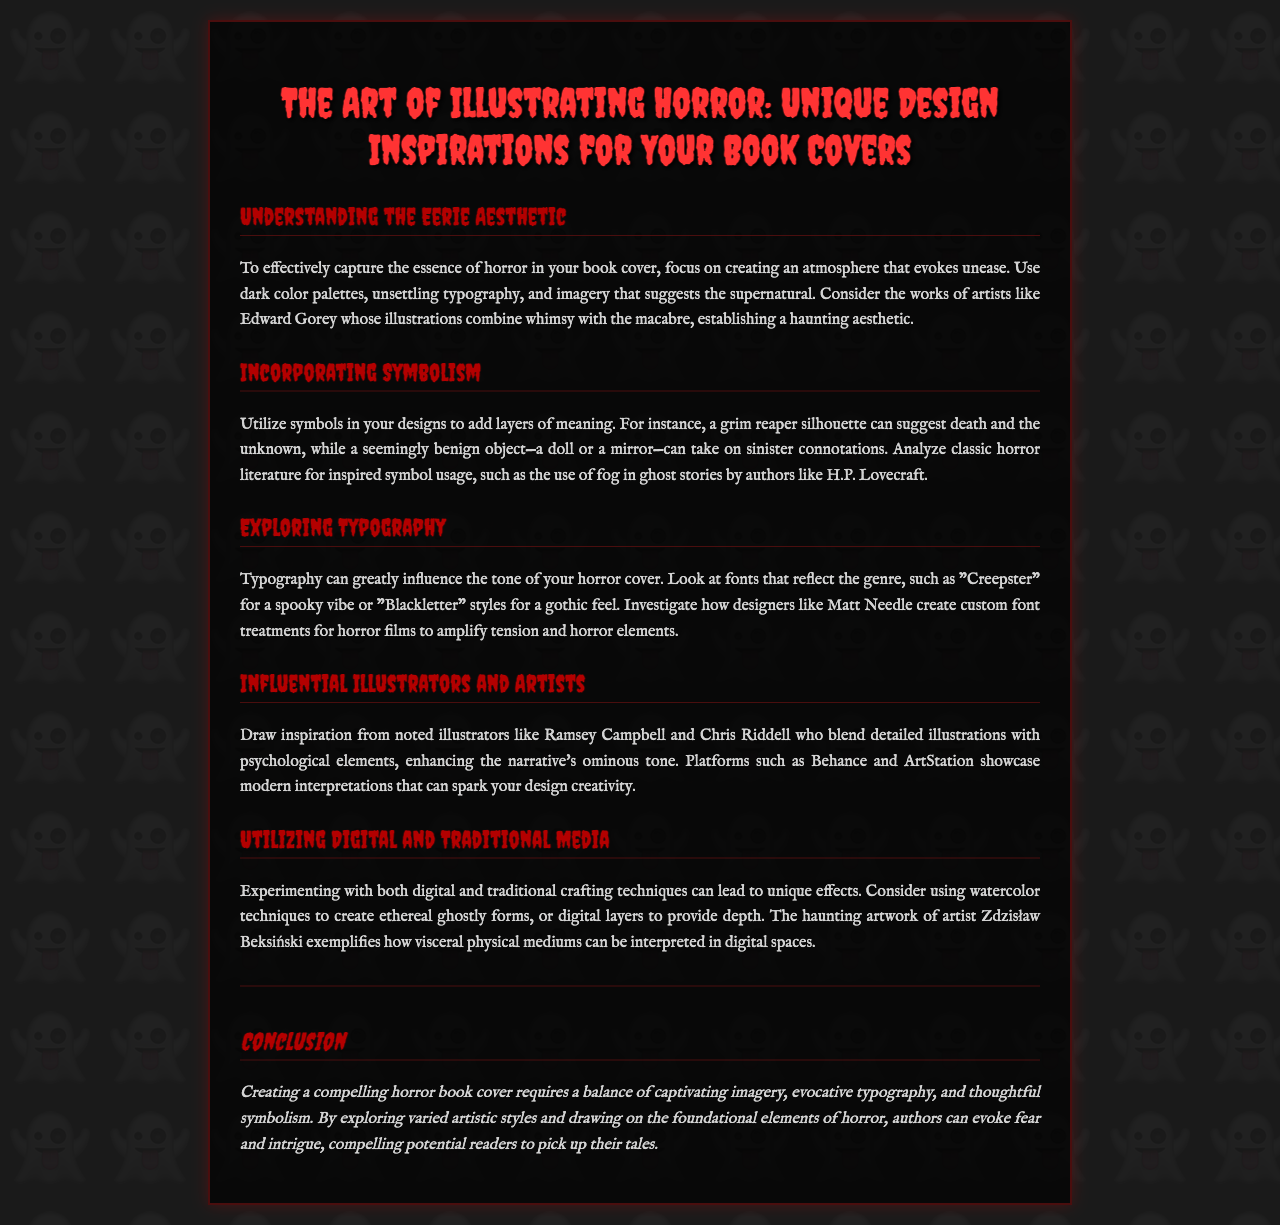what is the title of the brochure? The title is prominently displayed at the top of the document.
Answer: The Art of Illustrating Horror: Unique Design Inspirations for Your Book Covers who is mentioned as an influential artist in the document? The document references several artists within its sections, one being mentioned as a notable illustrator.
Answer: Ramsey Campbell what type of typography is suggested for a spooky vibe? The document provides specific font recommendations that evoke the horror genre.
Answer: Creepster how many sections are there in the brochure? The document can be examined to count the number of distinct sections it contains.
Answer: Five what artistic technique is recommended for creating ghostly forms? The document discusses both digital and traditional techniques for artistic expression.
Answer: Watercolor techniques which horror author is referenced regarding symbolism? The content cites a specific author known for their use of fog in ghost stories.
Answer: H.P. Lovecraft what overall balance is required for a compelling horror cover? The document concludes with specific elements that need to be harmonized for effective design.
Answer: Captivating imagery, evocative typography, and thoughtful symbolism 